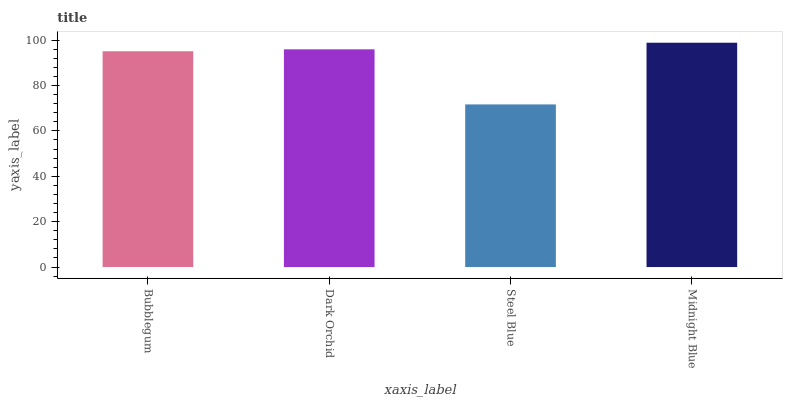Is Steel Blue the minimum?
Answer yes or no. Yes. Is Midnight Blue the maximum?
Answer yes or no. Yes. Is Dark Orchid the minimum?
Answer yes or no. No. Is Dark Orchid the maximum?
Answer yes or no. No. Is Dark Orchid greater than Bubblegum?
Answer yes or no. Yes. Is Bubblegum less than Dark Orchid?
Answer yes or no. Yes. Is Bubblegum greater than Dark Orchid?
Answer yes or no. No. Is Dark Orchid less than Bubblegum?
Answer yes or no. No. Is Dark Orchid the high median?
Answer yes or no. Yes. Is Bubblegum the low median?
Answer yes or no. Yes. Is Bubblegum the high median?
Answer yes or no. No. Is Midnight Blue the low median?
Answer yes or no. No. 